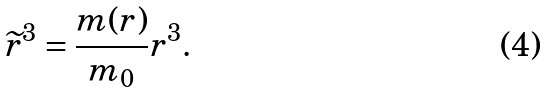<formula> <loc_0><loc_0><loc_500><loc_500>\widetilde { r } ^ { 3 } = \frac { m ( r ) } { m _ { 0 } } r ^ { 3 } .</formula> 